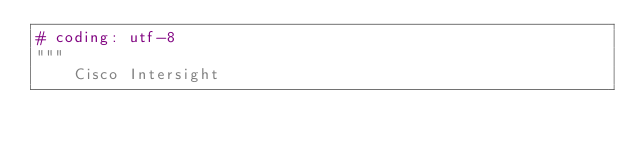Convert code to text. <code><loc_0><loc_0><loc_500><loc_500><_Python_># coding: utf-8
"""
    Cisco Intersight
</code> 